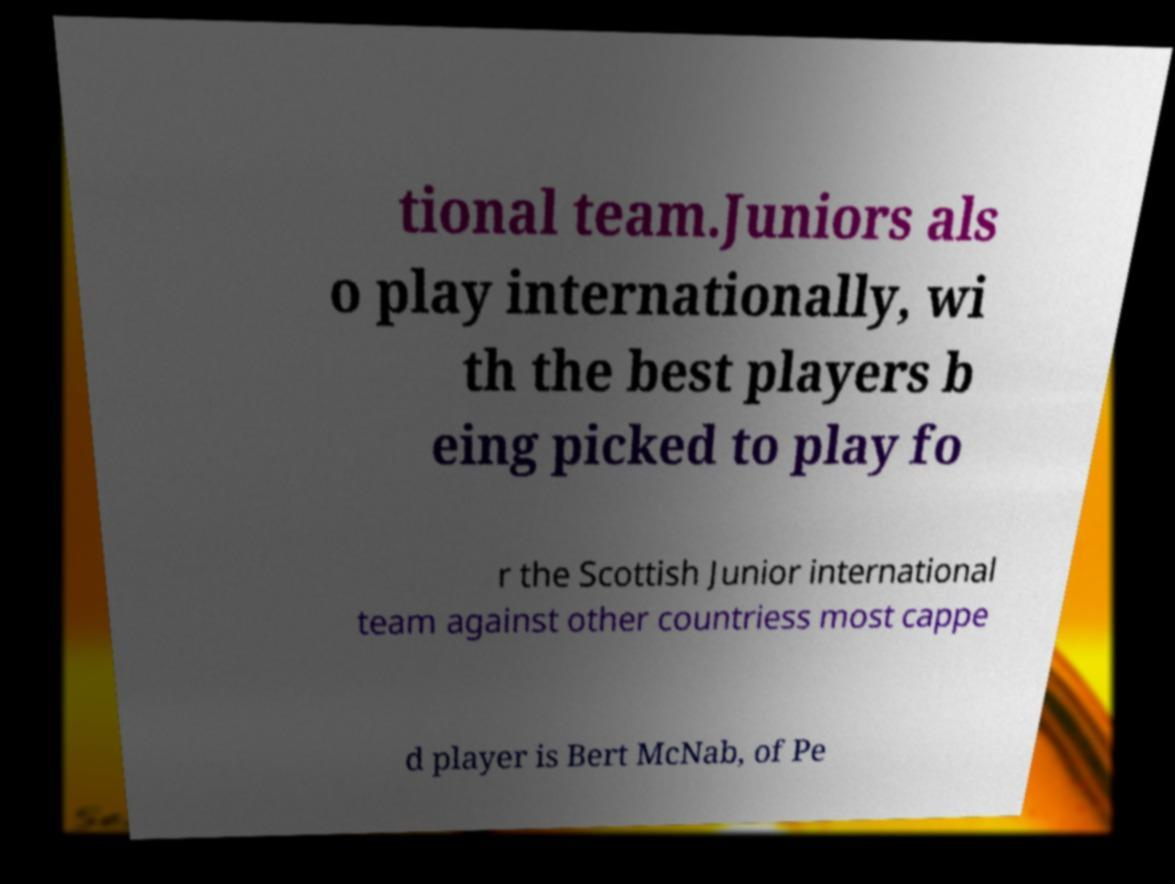For documentation purposes, I need the text within this image transcribed. Could you provide that? tional team.Juniors als o play internationally, wi th the best players b eing picked to play fo r the Scottish Junior international team against other countriess most cappe d player is Bert McNab, of Pe 